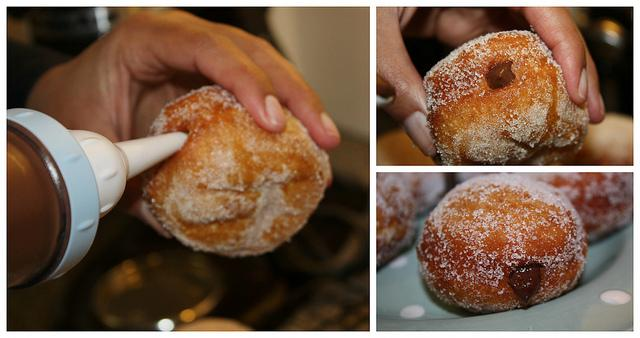What does the container hold?

Choices:
A) jelly
B) cream
C) sugar
D) butter jelly 